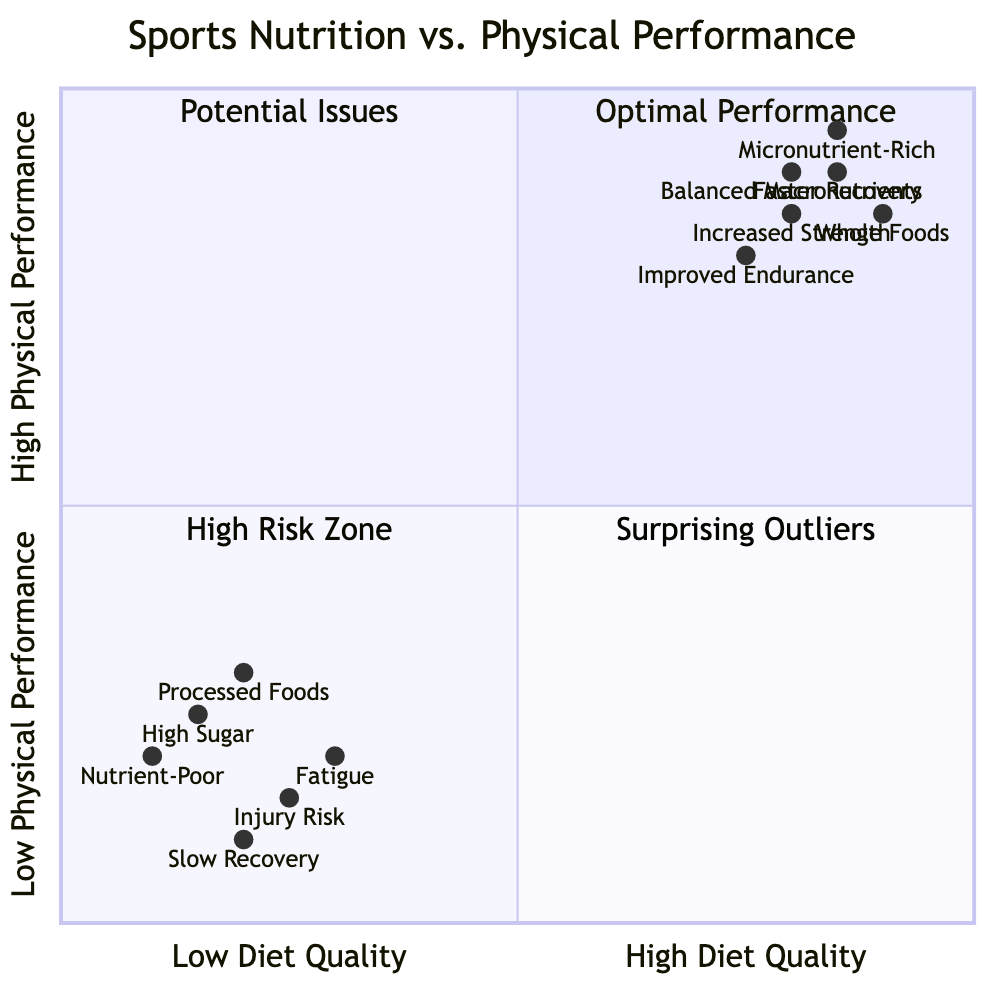What is the title of the diagram? The title, as stated in the diagram, is the first element presented. It clearly conveys the subject matter being analyzed, which is about nutrition and athletic performance.
Answer: Sports Nutrition vs. Physical Performance In which quadrant is "Improved Endurance" located? The diagram indicates positions for various elements based on their diet quality and performance categories. "Improved Endurance" is associated with high diet quality and high physical performance.
Answer: Optimal Performance What are the characteristics of diets in the "High Risk Zone" quadrant? This quadrant includes athletes with low-quality diets but still achieving high performance temporarily. The characteristics listed for this zone include genetic factors and unsustainable food choices leading to potential future health issues.
Answer: Fast food, sugary snacks, soft drinks How do athletes with "Low Diet Quality" and "Low Physical Performance" typically perform? The diagram categorizes this group in the "High Risk Zone," indicating significant negative performance impacts due to poor nutrition. Their performance is characterized by consistent fatigue and a high likelihood of injury.
Answer: Struggling to finish workouts, frequent injuries, prolonged soreness Which specific dietary element is positioned closest to the "High Diet Quality" axis? By examining the coordinates on the diagram, elements represented are placed based on their quality. "Whole Foods" has the highest coordinates along the diet quality axis, making it closest to high quality.
Answer: Whole Foods What is the relationship between "Balanced Macronutrients" and physical performance? The location of "Balanced Macronutrients" in the chart indicates that it positively impacts physical performance, positioning it in the "Optimal Performance" segment of the quadrant. This suggests its effectiveness in enhancing athletic output.
Answer: Strong positive relationship What performance effects can be expected from "Nutrient-Poor" diets? This element categorizes athletes in the "High Risk Zone" quadrant, indicating adverse effects on performance such as fatigue and slow recovery; thus, its low-quality nutrition leads to negative results.
Answer: Fatigue, injury risk, slow recovery How many examples fall within the "Potential Issues" quadrant? Analyzing the quadrant descriptions and examples listed, only one set falls into the "Potential Issues," where athletes with high-quality diets exhibit low performance potentially due to other factors.
Answer: 1 